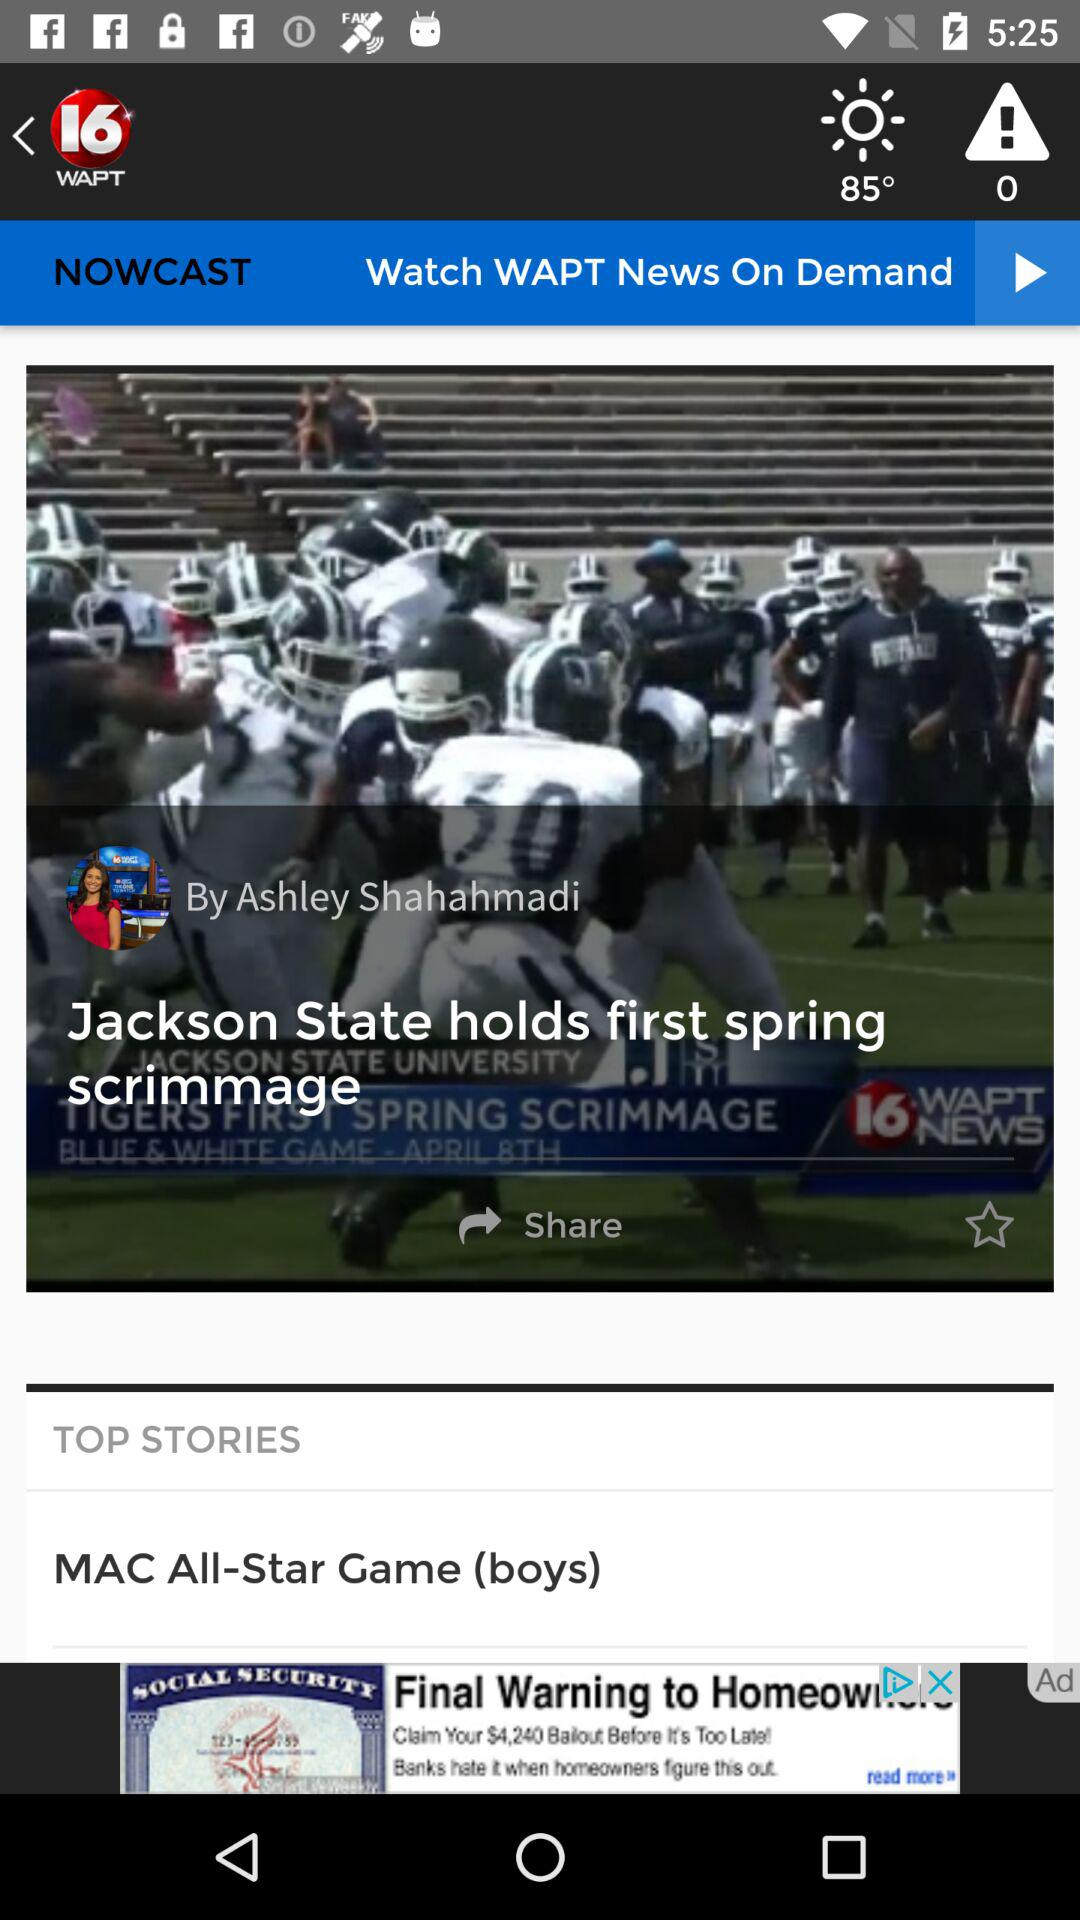What is the headline? The headlines are "Jackson State holds first spring scrimmage" and "MAC All-Star Game (boys)". 